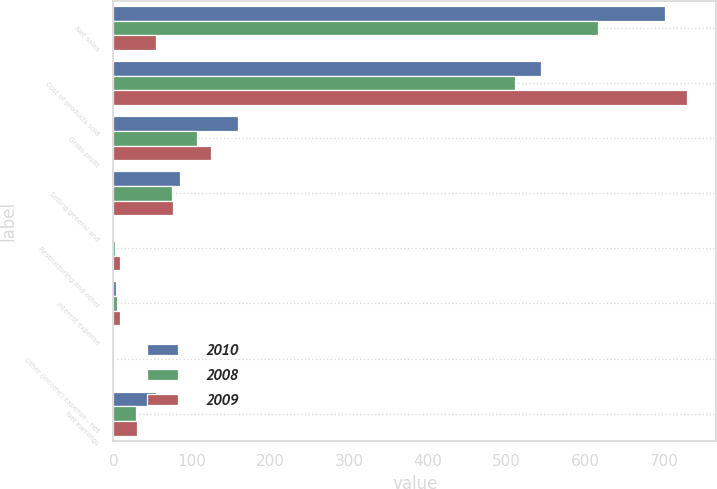Convert chart. <chart><loc_0><loc_0><loc_500><loc_500><stacked_bar_chart><ecel><fcel>Net sales<fcel>Cost of products sold<fcel>Gross profit<fcel>Selling general and<fcel>Restructuring and other<fcel>Interest expense<fcel>Other (income) expense - net<fcel>Net earnings<nl><fcel>2010<fcel>701.8<fcel>544<fcel>157.8<fcel>84.2<fcel>0.1<fcel>3.6<fcel>0.7<fcel>54.4<nl><fcel>2008<fcel>616.5<fcel>510.5<fcel>106<fcel>74.8<fcel>1.6<fcel>4.7<fcel>0.3<fcel>29.1<nl><fcel>2009<fcel>54.4<fcel>730<fcel>123.6<fcel>76<fcel>8.7<fcel>8.8<fcel>0.3<fcel>30.4<nl></chart> 